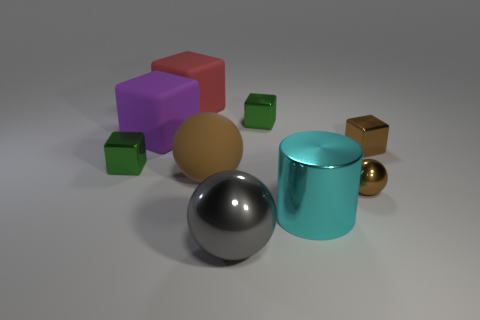Is the color of the tiny ball the same as the big rubber ball?
Offer a very short reply. Yes. The small green shiny thing that is to the right of the large rubber sphere has what shape?
Your response must be concise. Cube. What number of tiny objects are behind the small metallic ball and right of the cyan shiny cylinder?
Your response must be concise. 1. What number of other things are there of the same size as the brown metallic ball?
Provide a short and direct response. 3. Does the small green object right of the big red block have the same shape as the tiny metal object to the left of the big brown matte ball?
Keep it short and to the point. Yes. How many things are red matte cubes or small green shiny things behind the brown metal cube?
Ensure brevity in your answer.  2. The big object that is right of the red cube and behind the cyan shiny object is made of what material?
Your response must be concise. Rubber. Is there any other thing that has the same shape as the large cyan thing?
Keep it short and to the point. No. What color is the cube that is made of the same material as the big purple object?
Offer a terse response. Red. What number of objects are either green shiny things or small blue shiny things?
Your answer should be compact. 2. 